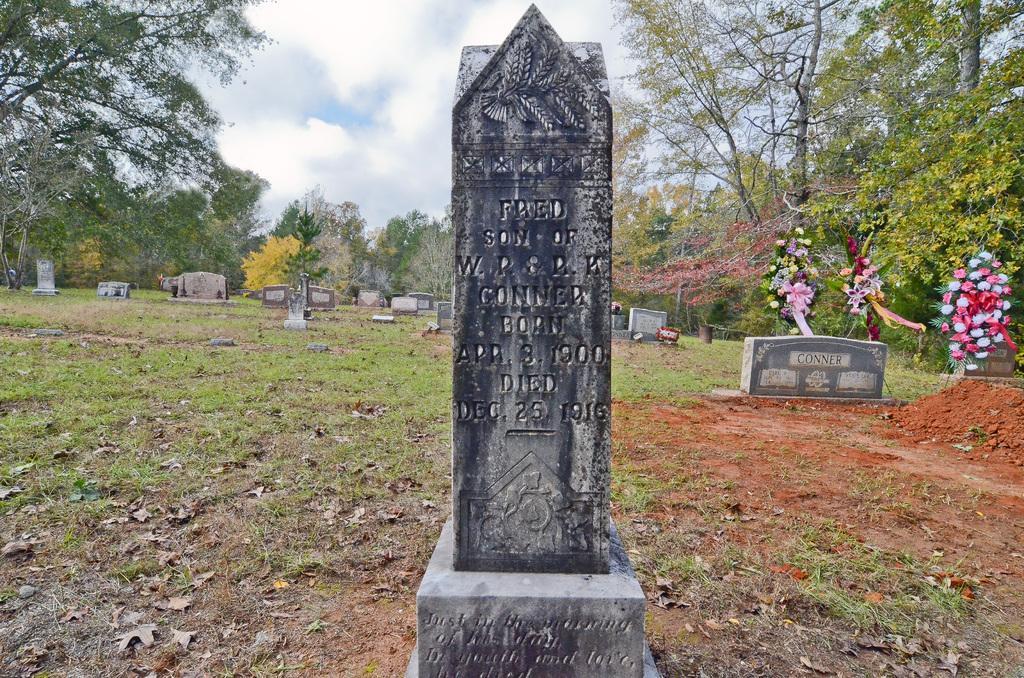Could you give a brief overview of what you see in this image? In the picture I can see gravestones. In the background I can see flowers, trees, the grass and the sky. 